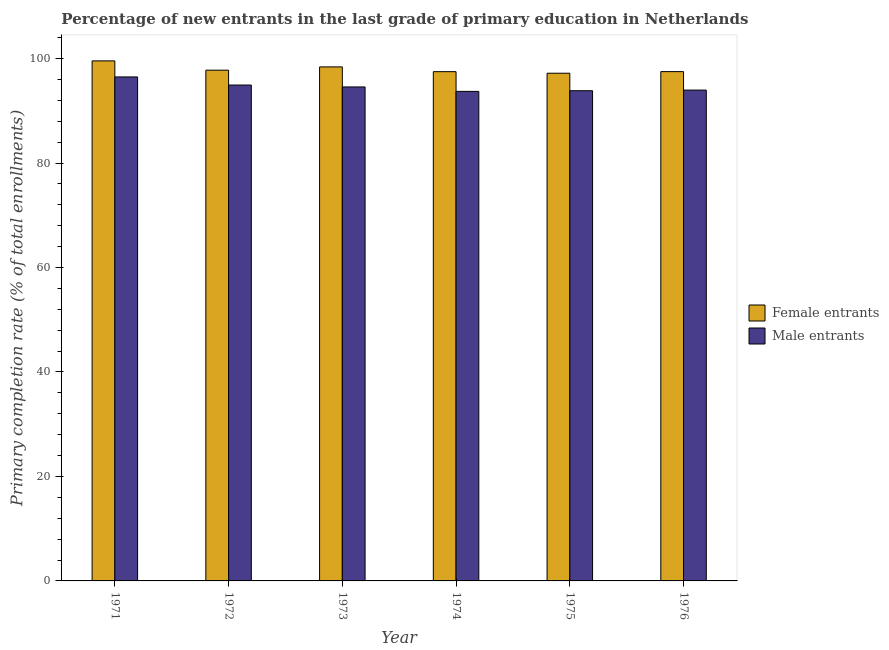Are the number of bars on each tick of the X-axis equal?
Offer a very short reply. Yes. How many bars are there on the 6th tick from the right?
Provide a short and direct response. 2. What is the label of the 4th group of bars from the left?
Your response must be concise. 1974. What is the primary completion rate of male entrants in 1971?
Your response must be concise. 96.48. Across all years, what is the maximum primary completion rate of male entrants?
Offer a very short reply. 96.48. Across all years, what is the minimum primary completion rate of female entrants?
Ensure brevity in your answer.  97.19. In which year was the primary completion rate of male entrants maximum?
Your answer should be very brief. 1971. In which year was the primary completion rate of female entrants minimum?
Provide a short and direct response. 1975. What is the total primary completion rate of female entrants in the graph?
Offer a very short reply. 587.92. What is the difference between the primary completion rate of male entrants in 1971 and that in 1973?
Make the answer very short. 1.92. What is the difference between the primary completion rate of male entrants in 1973 and the primary completion rate of female entrants in 1972?
Offer a terse response. -0.37. What is the average primary completion rate of female entrants per year?
Offer a terse response. 97.99. What is the ratio of the primary completion rate of female entrants in 1971 to that in 1973?
Keep it short and to the point. 1.01. What is the difference between the highest and the second highest primary completion rate of male entrants?
Your answer should be very brief. 1.55. What is the difference between the highest and the lowest primary completion rate of male entrants?
Offer a terse response. 2.77. Is the sum of the primary completion rate of male entrants in 1971 and 1974 greater than the maximum primary completion rate of female entrants across all years?
Your response must be concise. Yes. What does the 1st bar from the left in 1972 represents?
Give a very brief answer. Female entrants. What does the 2nd bar from the right in 1974 represents?
Keep it short and to the point. Female entrants. How many years are there in the graph?
Offer a terse response. 6. Does the graph contain any zero values?
Offer a terse response. No. Does the graph contain grids?
Your answer should be very brief. No. How are the legend labels stacked?
Your answer should be compact. Vertical. What is the title of the graph?
Your response must be concise. Percentage of new entrants in the last grade of primary education in Netherlands. What is the label or title of the Y-axis?
Your answer should be very brief. Primary completion rate (% of total enrollments). What is the Primary completion rate (% of total enrollments) in Female entrants in 1971?
Your answer should be very brief. 99.56. What is the Primary completion rate (% of total enrollments) in Male entrants in 1971?
Offer a terse response. 96.48. What is the Primary completion rate (% of total enrollments) of Female entrants in 1972?
Offer a very short reply. 97.78. What is the Primary completion rate (% of total enrollments) in Male entrants in 1972?
Offer a very short reply. 94.93. What is the Primary completion rate (% of total enrollments) in Female entrants in 1973?
Provide a short and direct response. 98.4. What is the Primary completion rate (% of total enrollments) in Male entrants in 1973?
Your answer should be compact. 94.57. What is the Primary completion rate (% of total enrollments) in Female entrants in 1974?
Make the answer very short. 97.49. What is the Primary completion rate (% of total enrollments) in Male entrants in 1974?
Ensure brevity in your answer.  93.72. What is the Primary completion rate (% of total enrollments) in Female entrants in 1975?
Make the answer very short. 97.19. What is the Primary completion rate (% of total enrollments) in Male entrants in 1975?
Your answer should be very brief. 93.84. What is the Primary completion rate (% of total enrollments) in Female entrants in 1976?
Provide a succinct answer. 97.5. What is the Primary completion rate (% of total enrollments) in Male entrants in 1976?
Your response must be concise. 93.97. Across all years, what is the maximum Primary completion rate (% of total enrollments) of Female entrants?
Your answer should be very brief. 99.56. Across all years, what is the maximum Primary completion rate (% of total enrollments) of Male entrants?
Provide a succinct answer. 96.48. Across all years, what is the minimum Primary completion rate (% of total enrollments) in Female entrants?
Your answer should be very brief. 97.19. Across all years, what is the minimum Primary completion rate (% of total enrollments) of Male entrants?
Ensure brevity in your answer.  93.72. What is the total Primary completion rate (% of total enrollments) of Female entrants in the graph?
Your answer should be compact. 587.92. What is the total Primary completion rate (% of total enrollments) of Male entrants in the graph?
Give a very brief answer. 567.51. What is the difference between the Primary completion rate (% of total enrollments) in Female entrants in 1971 and that in 1972?
Make the answer very short. 1.78. What is the difference between the Primary completion rate (% of total enrollments) of Male entrants in 1971 and that in 1972?
Your response must be concise. 1.55. What is the difference between the Primary completion rate (% of total enrollments) in Female entrants in 1971 and that in 1973?
Provide a short and direct response. 1.15. What is the difference between the Primary completion rate (% of total enrollments) in Male entrants in 1971 and that in 1973?
Provide a succinct answer. 1.92. What is the difference between the Primary completion rate (% of total enrollments) in Female entrants in 1971 and that in 1974?
Your response must be concise. 2.06. What is the difference between the Primary completion rate (% of total enrollments) in Male entrants in 1971 and that in 1974?
Your response must be concise. 2.77. What is the difference between the Primary completion rate (% of total enrollments) of Female entrants in 1971 and that in 1975?
Offer a very short reply. 2.36. What is the difference between the Primary completion rate (% of total enrollments) of Male entrants in 1971 and that in 1975?
Offer a very short reply. 2.64. What is the difference between the Primary completion rate (% of total enrollments) of Female entrants in 1971 and that in 1976?
Offer a very short reply. 2.06. What is the difference between the Primary completion rate (% of total enrollments) in Male entrants in 1971 and that in 1976?
Provide a succinct answer. 2.52. What is the difference between the Primary completion rate (% of total enrollments) of Female entrants in 1972 and that in 1973?
Provide a short and direct response. -0.63. What is the difference between the Primary completion rate (% of total enrollments) of Male entrants in 1972 and that in 1973?
Keep it short and to the point. 0.37. What is the difference between the Primary completion rate (% of total enrollments) of Female entrants in 1972 and that in 1974?
Ensure brevity in your answer.  0.28. What is the difference between the Primary completion rate (% of total enrollments) in Male entrants in 1972 and that in 1974?
Provide a short and direct response. 1.21. What is the difference between the Primary completion rate (% of total enrollments) in Female entrants in 1972 and that in 1975?
Your answer should be very brief. 0.59. What is the difference between the Primary completion rate (% of total enrollments) of Male entrants in 1972 and that in 1975?
Give a very brief answer. 1.09. What is the difference between the Primary completion rate (% of total enrollments) in Female entrants in 1972 and that in 1976?
Provide a succinct answer. 0.28. What is the difference between the Primary completion rate (% of total enrollments) in Male entrants in 1972 and that in 1976?
Your response must be concise. 0.97. What is the difference between the Primary completion rate (% of total enrollments) in Female entrants in 1973 and that in 1974?
Your response must be concise. 0.91. What is the difference between the Primary completion rate (% of total enrollments) of Male entrants in 1973 and that in 1974?
Your answer should be compact. 0.85. What is the difference between the Primary completion rate (% of total enrollments) in Female entrants in 1973 and that in 1975?
Provide a short and direct response. 1.21. What is the difference between the Primary completion rate (% of total enrollments) of Male entrants in 1973 and that in 1975?
Keep it short and to the point. 0.73. What is the difference between the Primary completion rate (% of total enrollments) in Female entrants in 1973 and that in 1976?
Make the answer very short. 0.9. What is the difference between the Primary completion rate (% of total enrollments) in Male entrants in 1973 and that in 1976?
Your answer should be very brief. 0.6. What is the difference between the Primary completion rate (% of total enrollments) in Female entrants in 1974 and that in 1975?
Make the answer very short. 0.3. What is the difference between the Primary completion rate (% of total enrollments) of Male entrants in 1974 and that in 1975?
Your answer should be very brief. -0.12. What is the difference between the Primary completion rate (% of total enrollments) of Female entrants in 1974 and that in 1976?
Keep it short and to the point. -0.01. What is the difference between the Primary completion rate (% of total enrollments) in Male entrants in 1974 and that in 1976?
Keep it short and to the point. -0.25. What is the difference between the Primary completion rate (% of total enrollments) of Female entrants in 1975 and that in 1976?
Give a very brief answer. -0.31. What is the difference between the Primary completion rate (% of total enrollments) of Male entrants in 1975 and that in 1976?
Provide a short and direct response. -0.12. What is the difference between the Primary completion rate (% of total enrollments) of Female entrants in 1971 and the Primary completion rate (% of total enrollments) of Male entrants in 1972?
Provide a short and direct response. 4.62. What is the difference between the Primary completion rate (% of total enrollments) in Female entrants in 1971 and the Primary completion rate (% of total enrollments) in Male entrants in 1973?
Provide a succinct answer. 4.99. What is the difference between the Primary completion rate (% of total enrollments) of Female entrants in 1971 and the Primary completion rate (% of total enrollments) of Male entrants in 1974?
Your answer should be compact. 5.84. What is the difference between the Primary completion rate (% of total enrollments) of Female entrants in 1971 and the Primary completion rate (% of total enrollments) of Male entrants in 1975?
Provide a succinct answer. 5.71. What is the difference between the Primary completion rate (% of total enrollments) in Female entrants in 1971 and the Primary completion rate (% of total enrollments) in Male entrants in 1976?
Provide a succinct answer. 5.59. What is the difference between the Primary completion rate (% of total enrollments) in Female entrants in 1972 and the Primary completion rate (% of total enrollments) in Male entrants in 1973?
Keep it short and to the point. 3.21. What is the difference between the Primary completion rate (% of total enrollments) of Female entrants in 1972 and the Primary completion rate (% of total enrollments) of Male entrants in 1974?
Your answer should be very brief. 4.06. What is the difference between the Primary completion rate (% of total enrollments) in Female entrants in 1972 and the Primary completion rate (% of total enrollments) in Male entrants in 1975?
Offer a very short reply. 3.94. What is the difference between the Primary completion rate (% of total enrollments) in Female entrants in 1972 and the Primary completion rate (% of total enrollments) in Male entrants in 1976?
Your answer should be compact. 3.81. What is the difference between the Primary completion rate (% of total enrollments) of Female entrants in 1973 and the Primary completion rate (% of total enrollments) of Male entrants in 1974?
Keep it short and to the point. 4.69. What is the difference between the Primary completion rate (% of total enrollments) in Female entrants in 1973 and the Primary completion rate (% of total enrollments) in Male entrants in 1975?
Provide a succinct answer. 4.56. What is the difference between the Primary completion rate (% of total enrollments) of Female entrants in 1973 and the Primary completion rate (% of total enrollments) of Male entrants in 1976?
Make the answer very short. 4.44. What is the difference between the Primary completion rate (% of total enrollments) in Female entrants in 1974 and the Primary completion rate (% of total enrollments) in Male entrants in 1975?
Keep it short and to the point. 3.65. What is the difference between the Primary completion rate (% of total enrollments) of Female entrants in 1974 and the Primary completion rate (% of total enrollments) of Male entrants in 1976?
Your answer should be compact. 3.53. What is the difference between the Primary completion rate (% of total enrollments) of Female entrants in 1975 and the Primary completion rate (% of total enrollments) of Male entrants in 1976?
Offer a very short reply. 3.23. What is the average Primary completion rate (% of total enrollments) in Female entrants per year?
Offer a very short reply. 97.99. What is the average Primary completion rate (% of total enrollments) of Male entrants per year?
Make the answer very short. 94.59. In the year 1971, what is the difference between the Primary completion rate (% of total enrollments) of Female entrants and Primary completion rate (% of total enrollments) of Male entrants?
Keep it short and to the point. 3.07. In the year 1972, what is the difference between the Primary completion rate (% of total enrollments) of Female entrants and Primary completion rate (% of total enrollments) of Male entrants?
Your answer should be compact. 2.84. In the year 1973, what is the difference between the Primary completion rate (% of total enrollments) of Female entrants and Primary completion rate (% of total enrollments) of Male entrants?
Make the answer very short. 3.84. In the year 1974, what is the difference between the Primary completion rate (% of total enrollments) of Female entrants and Primary completion rate (% of total enrollments) of Male entrants?
Provide a succinct answer. 3.78. In the year 1975, what is the difference between the Primary completion rate (% of total enrollments) of Female entrants and Primary completion rate (% of total enrollments) of Male entrants?
Ensure brevity in your answer.  3.35. In the year 1976, what is the difference between the Primary completion rate (% of total enrollments) of Female entrants and Primary completion rate (% of total enrollments) of Male entrants?
Your answer should be compact. 3.53. What is the ratio of the Primary completion rate (% of total enrollments) of Female entrants in 1971 to that in 1972?
Offer a terse response. 1.02. What is the ratio of the Primary completion rate (% of total enrollments) in Male entrants in 1971 to that in 1972?
Keep it short and to the point. 1.02. What is the ratio of the Primary completion rate (% of total enrollments) of Female entrants in 1971 to that in 1973?
Give a very brief answer. 1.01. What is the ratio of the Primary completion rate (% of total enrollments) in Male entrants in 1971 to that in 1973?
Ensure brevity in your answer.  1.02. What is the ratio of the Primary completion rate (% of total enrollments) of Female entrants in 1971 to that in 1974?
Provide a succinct answer. 1.02. What is the ratio of the Primary completion rate (% of total enrollments) in Male entrants in 1971 to that in 1974?
Offer a terse response. 1.03. What is the ratio of the Primary completion rate (% of total enrollments) of Female entrants in 1971 to that in 1975?
Give a very brief answer. 1.02. What is the ratio of the Primary completion rate (% of total enrollments) of Male entrants in 1971 to that in 1975?
Provide a short and direct response. 1.03. What is the ratio of the Primary completion rate (% of total enrollments) of Female entrants in 1971 to that in 1976?
Your answer should be very brief. 1.02. What is the ratio of the Primary completion rate (% of total enrollments) in Male entrants in 1971 to that in 1976?
Provide a short and direct response. 1.03. What is the ratio of the Primary completion rate (% of total enrollments) of Female entrants in 1972 to that in 1973?
Provide a short and direct response. 0.99. What is the ratio of the Primary completion rate (% of total enrollments) of Male entrants in 1972 to that in 1974?
Keep it short and to the point. 1.01. What is the ratio of the Primary completion rate (% of total enrollments) in Male entrants in 1972 to that in 1975?
Your answer should be compact. 1.01. What is the ratio of the Primary completion rate (% of total enrollments) of Female entrants in 1972 to that in 1976?
Your answer should be very brief. 1. What is the ratio of the Primary completion rate (% of total enrollments) of Male entrants in 1972 to that in 1976?
Make the answer very short. 1.01. What is the ratio of the Primary completion rate (% of total enrollments) in Female entrants in 1973 to that in 1974?
Make the answer very short. 1.01. What is the ratio of the Primary completion rate (% of total enrollments) of Male entrants in 1973 to that in 1974?
Make the answer very short. 1.01. What is the ratio of the Primary completion rate (% of total enrollments) of Female entrants in 1973 to that in 1975?
Your answer should be compact. 1.01. What is the ratio of the Primary completion rate (% of total enrollments) of Male entrants in 1973 to that in 1975?
Your response must be concise. 1.01. What is the ratio of the Primary completion rate (% of total enrollments) in Female entrants in 1973 to that in 1976?
Keep it short and to the point. 1.01. What is the ratio of the Primary completion rate (% of total enrollments) of Male entrants in 1973 to that in 1976?
Offer a very short reply. 1.01. What is the ratio of the Primary completion rate (% of total enrollments) in Female entrants in 1974 to that in 1975?
Give a very brief answer. 1. What is the difference between the highest and the second highest Primary completion rate (% of total enrollments) of Female entrants?
Ensure brevity in your answer.  1.15. What is the difference between the highest and the second highest Primary completion rate (% of total enrollments) of Male entrants?
Your response must be concise. 1.55. What is the difference between the highest and the lowest Primary completion rate (% of total enrollments) of Female entrants?
Make the answer very short. 2.36. What is the difference between the highest and the lowest Primary completion rate (% of total enrollments) of Male entrants?
Make the answer very short. 2.77. 